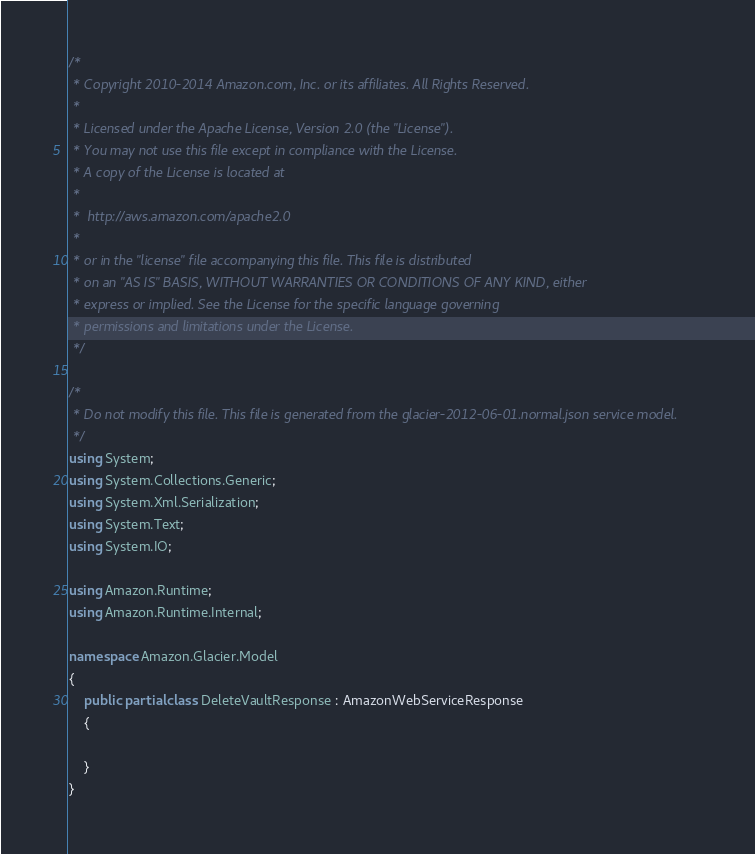Convert code to text. <code><loc_0><loc_0><loc_500><loc_500><_C#_>/*
 * Copyright 2010-2014 Amazon.com, Inc. or its affiliates. All Rights Reserved.
 * 
 * Licensed under the Apache License, Version 2.0 (the "License").
 * You may not use this file except in compliance with the License.
 * A copy of the License is located at
 * 
 *  http://aws.amazon.com/apache2.0
 * 
 * or in the "license" file accompanying this file. This file is distributed
 * on an "AS IS" BASIS, WITHOUT WARRANTIES OR CONDITIONS OF ANY KIND, either
 * express or implied. See the License for the specific language governing
 * permissions and limitations under the License.
 */

/*
 * Do not modify this file. This file is generated from the glacier-2012-06-01.normal.json service model.
 */
using System;
using System.Collections.Generic;
using System.Xml.Serialization;
using System.Text;
using System.IO;

using Amazon.Runtime;
using Amazon.Runtime.Internal;

namespace Amazon.Glacier.Model
{
    public partial class DeleteVaultResponse : AmazonWebServiceResponse
    {

    }
}</code> 